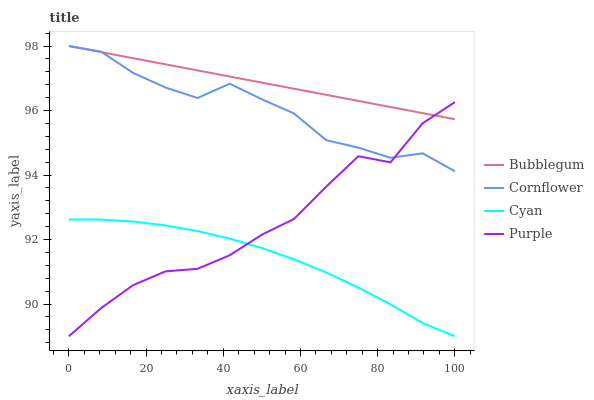Does Cornflower have the minimum area under the curve?
Answer yes or no. No. Does Cornflower have the maximum area under the curve?
Answer yes or no. No. Is Cornflower the smoothest?
Answer yes or no. No. Is Cornflower the roughest?
Answer yes or no. No. Does Cornflower have the lowest value?
Answer yes or no. No. Does Cyan have the highest value?
Answer yes or no. No. Is Cyan less than Cornflower?
Answer yes or no. Yes. Is Cornflower greater than Cyan?
Answer yes or no. Yes. Does Cyan intersect Cornflower?
Answer yes or no. No. 